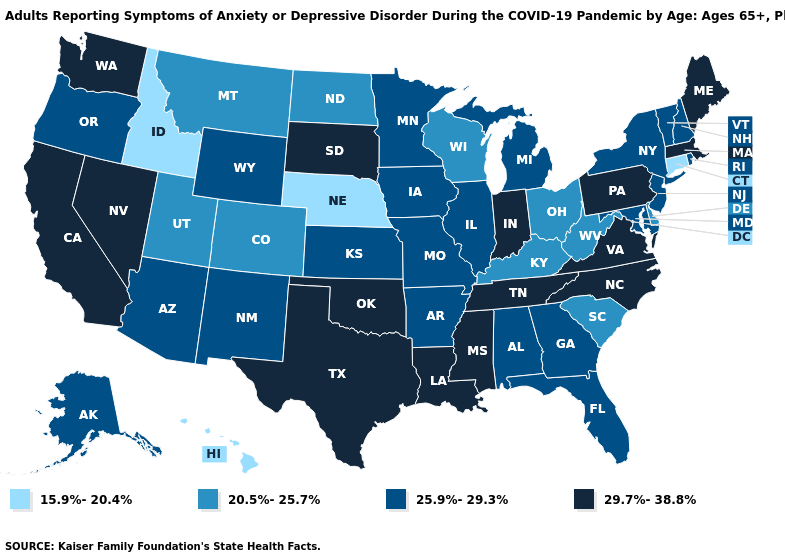Name the states that have a value in the range 20.5%-25.7%?
Short answer required. Colorado, Delaware, Kentucky, Montana, North Dakota, Ohio, South Carolina, Utah, West Virginia, Wisconsin. Among the states that border Tennessee , does Kentucky have the lowest value?
Give a very brief answer. Yes. Does Indiana have the same value as California?
Keep it brief. Yes. How many symbols are there in the legend?
Give a very brief answer. 4. Does Oklahoma have the same value as Indiana?
Short answer required. Yes. Name the states that have a value in the range 20.5%-25.7%?
Answer briefly. Colorado, Delaware, Kentucky, Montana, North Dakota, Ohio, South Carolina, Utah, West Virginia, Wisconsin. What is the lowest value in states that border Washington?
Keep it brief. 15.9%-20.4%. What is the highest value in the USA?
Concise answer only. 29.7%-38.8%. Name the states that have a value in the range 20.5%-25.7%?
Quick response, please. Colorado, Delaware, Kentucky, Montana, North Dakota, Ohio, South Carolina, Utah, West Virginia, Wisconsin. Does Delaware have the highest value in the USA?
Keep it brief. No. What is the value of Maryland?
Short answer required. 25.9%-29.3%. Among the states that border South Carolina , does North Carolina have the highest value?
Keep it brief. Yes. What is the value of Washington?
Short answer required. 29.7%-38.8%. Which states hav the highest value in the West?
Concise answer only. California, Nevada, Washington. Among the states that border Nevada , does Idaho have the lowest value?
Short answer required. Yes. 